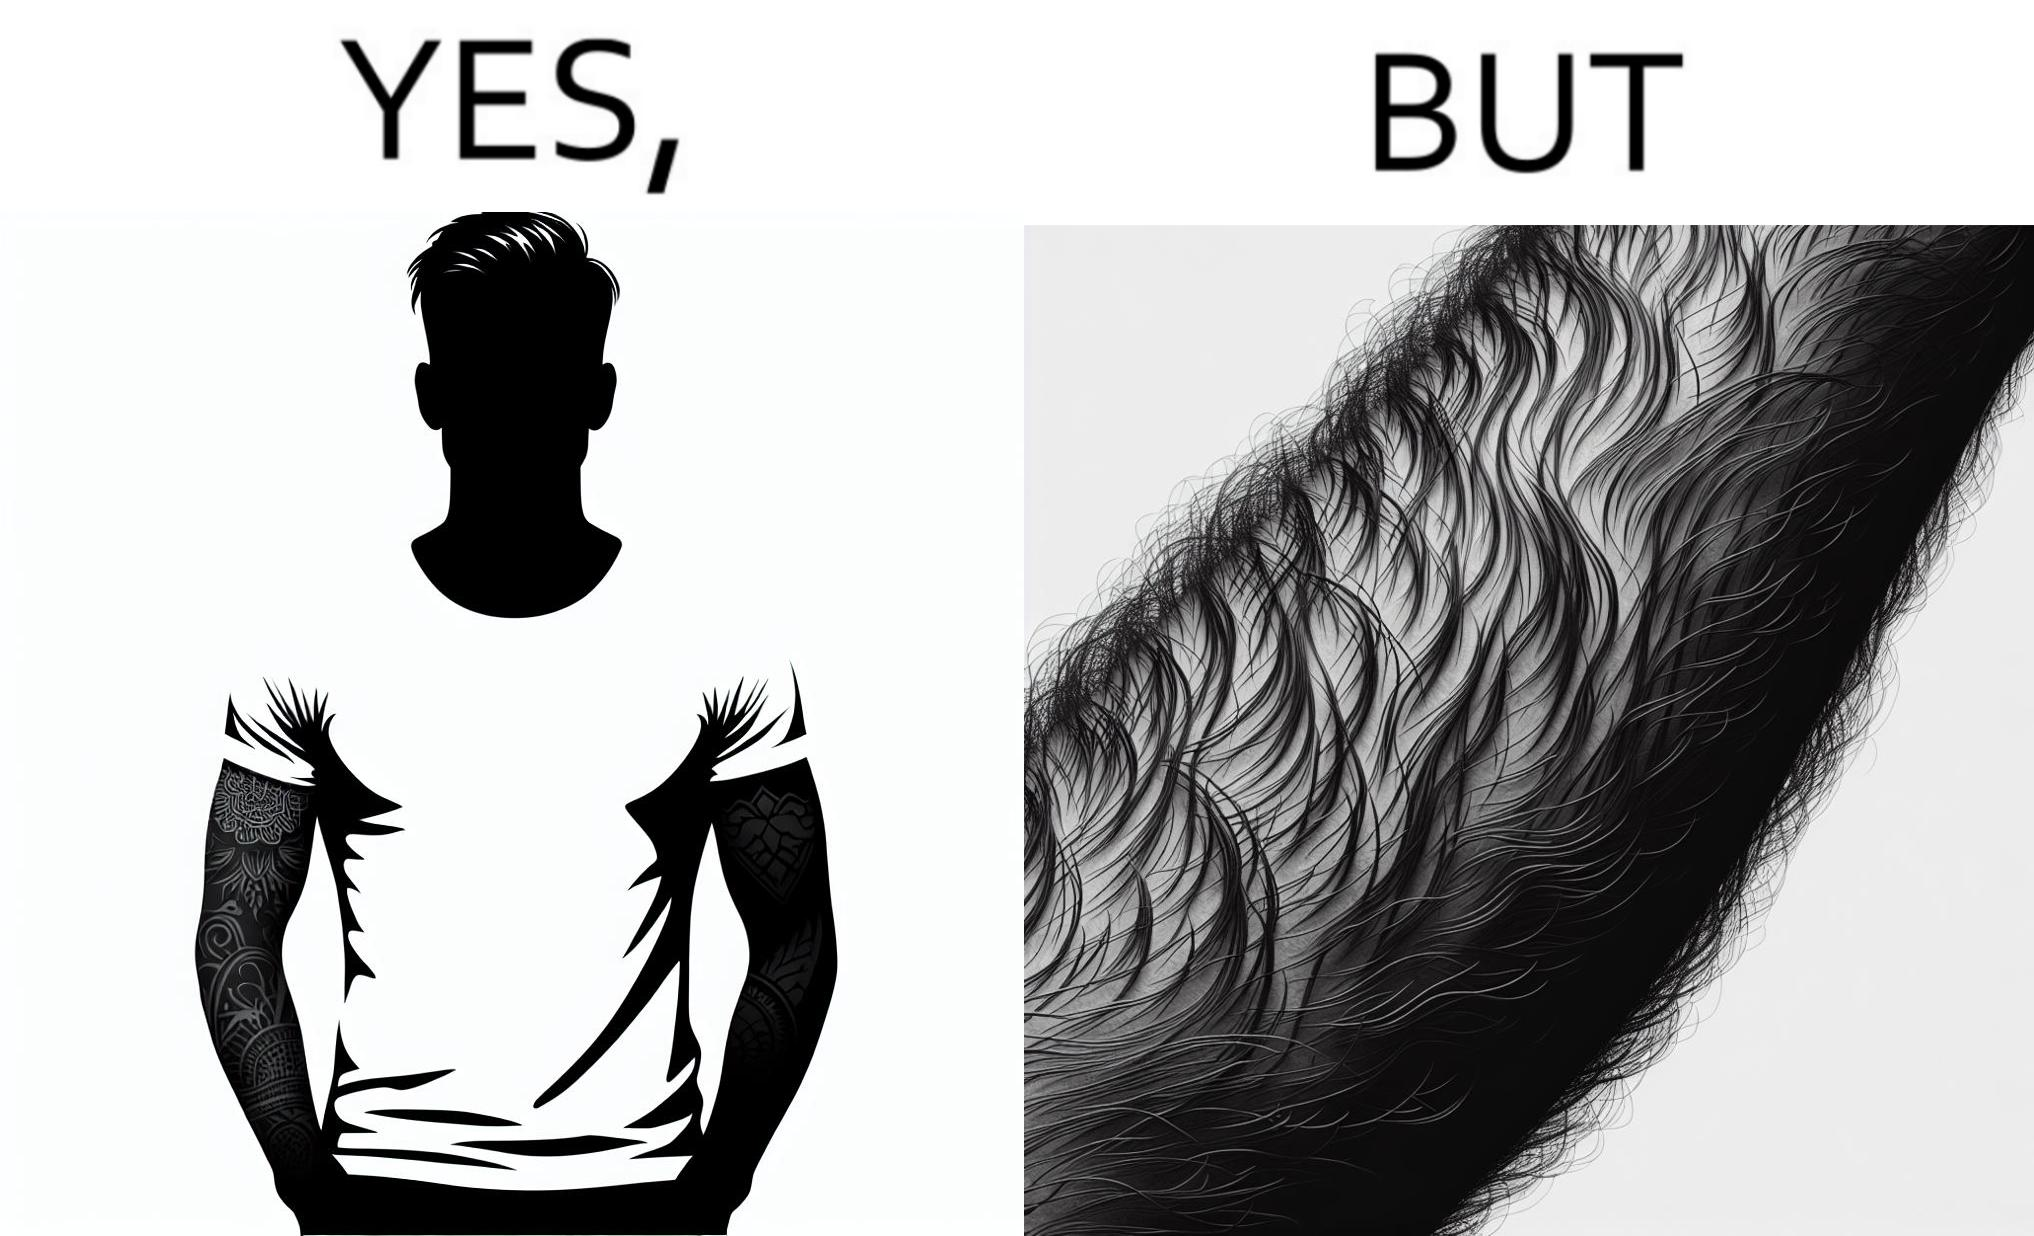Does this image contain satire or humor? Yes, this image is satirical. 